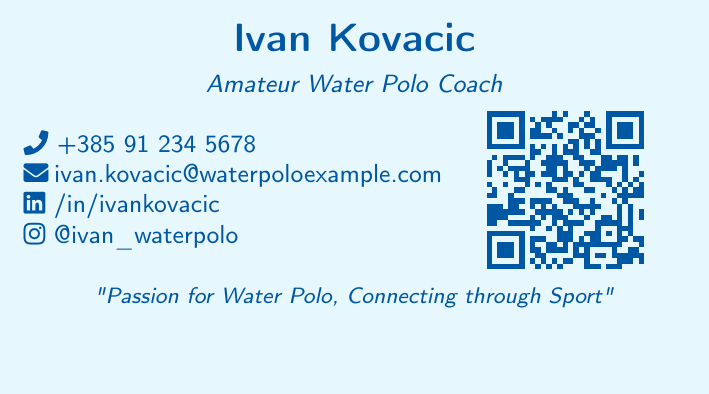What is the name of the individual? The document prominently displays the individual’s name at the top.
Answer: Ivan Kovacic What is the profession listed on the card? It specifies the role of the individual as an amateur water polo coach.
Answer: Amateur Water Polo Coach What is the phone number provided? The document includes a contact number, which is listed under the contact information.
Answer: +385 91 234 5678 What social media link is provided? The business card includes a LinkedIn profile address as part of the social media information.
Answer: /in/ivankovacic What event is mentioned on the card? The card highlights a specific water polo event with details following it.
Answer: Adriatic Water Polo Championship When is the event scheduled? The date of the water polo event is included below the event name.
Answer: June 25-27, 2023 What city will host the event? The document indicates the location of the event in a specific Croatian city.
Answer: Split What color scheme is used in the background? The color used for the background of the business card is specified, creating a distinctive aesthetic.
Answer: Cyan What is the message printed on the card? A motivational message related to water polo is shown on the card towards the bottom.
Answer: Passion for Water Polo, Connecting through Sport 